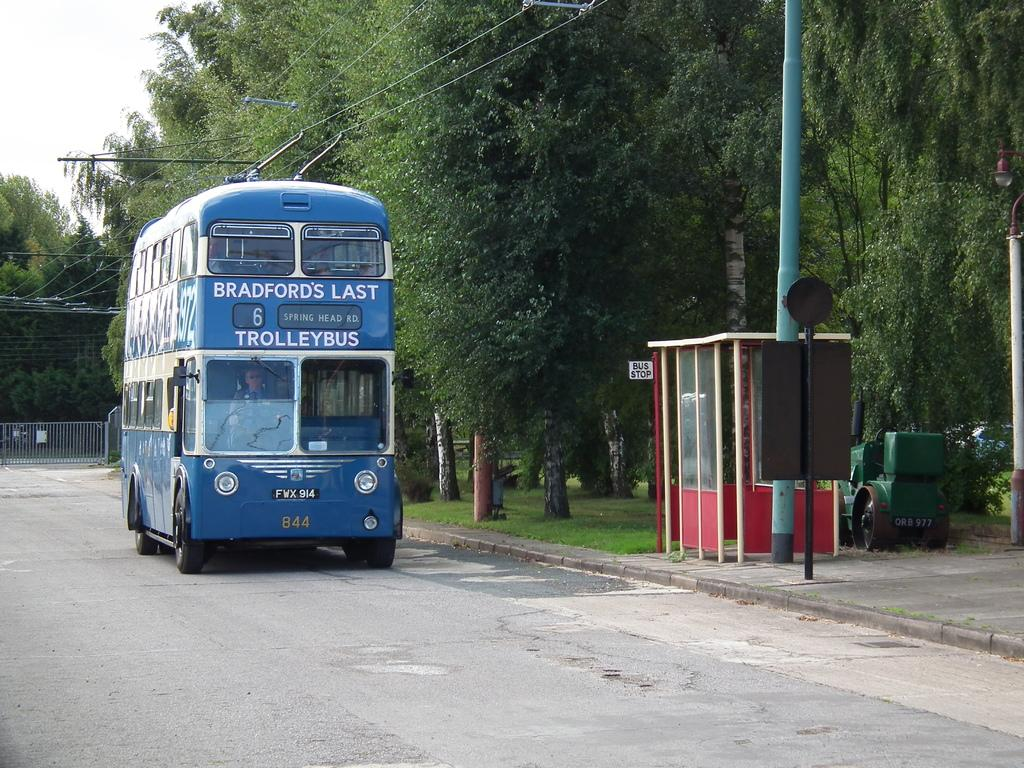<image>
Present a compact description of the photo's key features. Blue trolleybus which says Bradford's Last on top. 